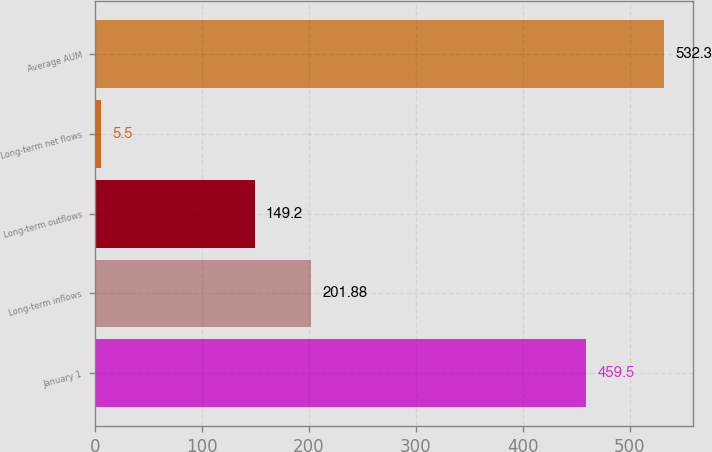<chart> <loc_0><loc_0><loc_500><loc_500><bar_chart><fcel>January 1<fcel>Long-term inflows<fcel>Long-term outflows<fcel>Long-term net flows<fcel>Average AUM<nl><fcel>459.5<fcel>201.88<fcel>149.2<fcel>5.5<fcel>532.3<nl></chart> 